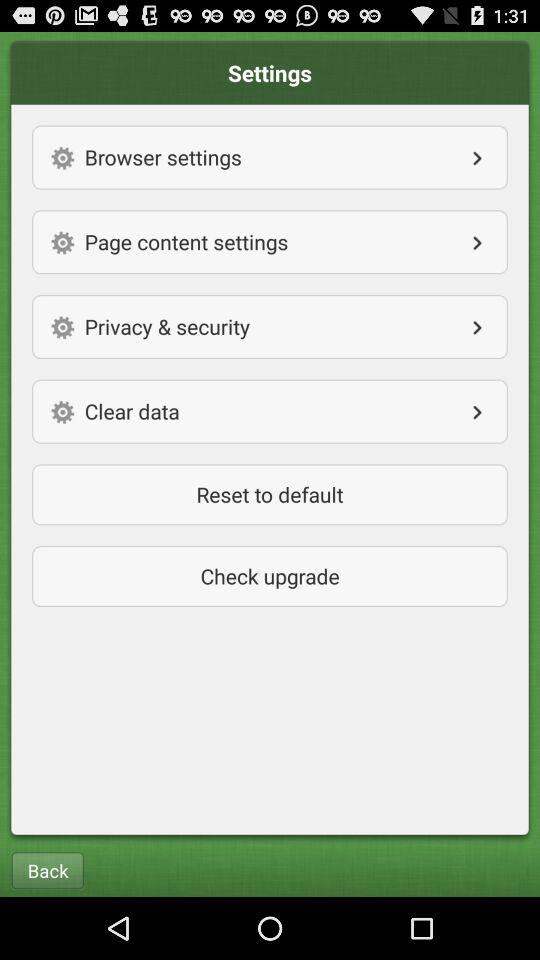How many settings are there on the screen?
Answer the question using a single word or phrase. 4 